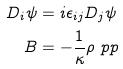<formula> <loc_0><loc_0><loc_500><loc_500>D _ { i } \psi & = i \epsilon _ { i j } D _ { j } \psi \\ B & = - \frac { 1 } { \kappa } \rho \ p p</formula> 